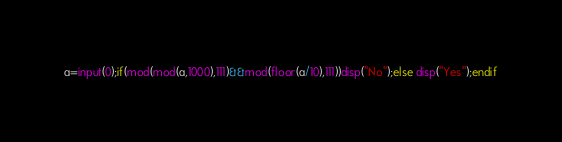<code> <loc_0><loc_0><loc_500><loc_500><_Octave_>a=input(0);if(mod(mod(a,1000),111)&&mod(floor(a/10),111))disp("No");else disp("Yes");endif</code> 